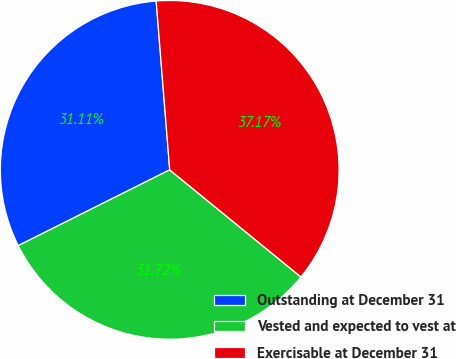Convert chart. <chart><loc_0><loc_0><loc_500><loc_500><pie_chart><fcel>Outstanding at December 31<fcel>Vested and expected to vest at<fcel>Exercisable at December 31<nl><fcel>31.11%<fcel>31.72%<fcel>37.17%<nl></chart> 